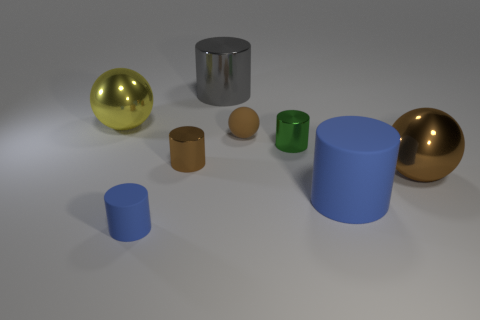Subtract all green balls. How many blue cylinders are left? 2 Add 2 tiny brown things. How many objects exist? 10 Subtract all rubber balls. How many balls are left? 2 Subtract 1 spheres. How many spheres are left? 2 Subtract all balls. How many objects are left? 5 Subtract all cyan balls. Subtract all blue blocks. How many balls are left? 3 Subtract all gray objects. Subtract all green metal objects. How many objects are left? 6 Add 5 green cylinders. How many green cylinders are left? 6 Add 4 tiny blue matte objects. How many tiny blue matte objects exist? 5 Subtract all blue cylinders. How many cylinders are left? 3 